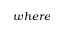<formula> <loc_0><loc_0><loc_500><loc_500>w h e r e</formula> 